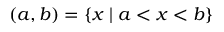<formula> <loc_0><loc_0><loc_500><loc_500>( a , b ) = \{ x | a < x < b \}</formula> 